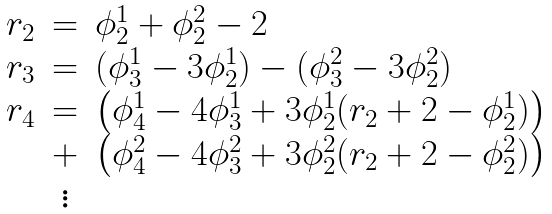<formula> <loc_0><loc_0><loc_500><loc_500>\begin{array} { l c l } r _ { 2 } & = & \phi _ { 2 } ^ { 1 } + \phi _ { 2 } ^ { 2 } - 2 \\ r _ { 3 } & = & ( \phi _ { 3 } ^ { 1 } - 3 \phi _ { 2 } ^ { 1 } ) - ( \phi _ { 3 } ^ { 2 } - 3 \phi _ { 2 } ^ { 2 } ) \\ r _ { 4 } & = & \left ( \phi _ { 4 } ^ { 1 } - 4 \phi _ { 3 } ^ { 1 } + 3 \phi _ { 2 } ^ { 1 } ( r _ { 2 } + 2 - \phi _ { 2 } ^ { 1 } ) \right ) \\ & + & \left ( \phi _ { 4 } ^ { 2 } - 4 \phi _ { 3 } ^ { 2 } + 3 \phi _ { 2 } ^ { 2 } ( r _ { 2 } + 2 - \phi _ { 2 } ^ { 2 } ) \right ) \\ & \vdots & \end{array}</formula> 